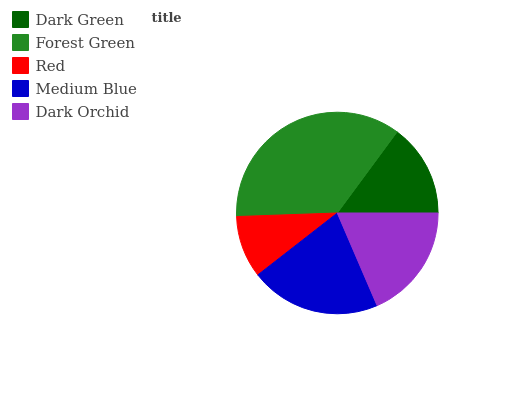Is Red the minimum?
Answer yes or no. Yes. Is Forest Green the maximum?
Answer yes or no. Yes. Is Forest Green the minimum?
Answer yes or no. No. Is Red the maximum?
Answer yes or no. No. Is Forest Green greater than Red?
Answer yes or no. Yes. Is Red less than Forest Green?
Answer yes or no. Yes. Is Red greater than Forest Green?
Answer yes or no. No. Is Forest Green less than Red?
Answer yes or no. No. Is Dark Orchid the high median?
Answer yes or no. Yes. Is Dark Orchid the low median?
Answer yes or no. Yes. Is Red the high median?
Answer yes or no. No. Is Medium Blue the low median?
Answer yes or no. No. 